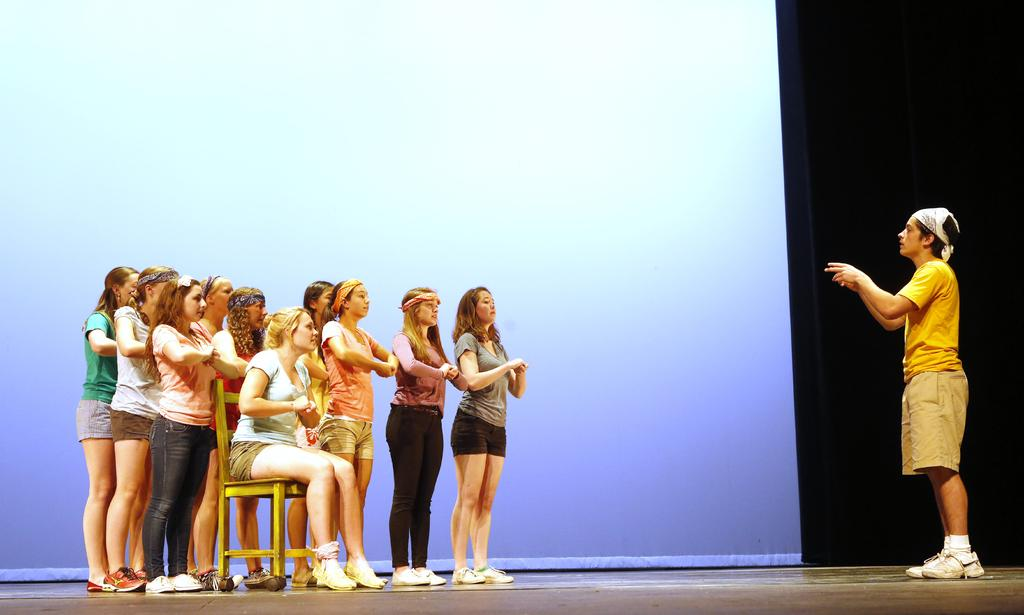What is the gender of the person standing on the right side of the image? The person standing on the right side of the image is a man. What color is the man wearing? The man is wearing yellow. What is the man doing in the image? The man is talking. What is the woman on the left side of the image doing? The woman is sitting on a chair. Where are the group of girls located in the image? The group of girls is standing on a stage. What type of smoke can be seen coming from the trucks in the image? There are no trucks present in the image, so there is no smoke to be seen. 